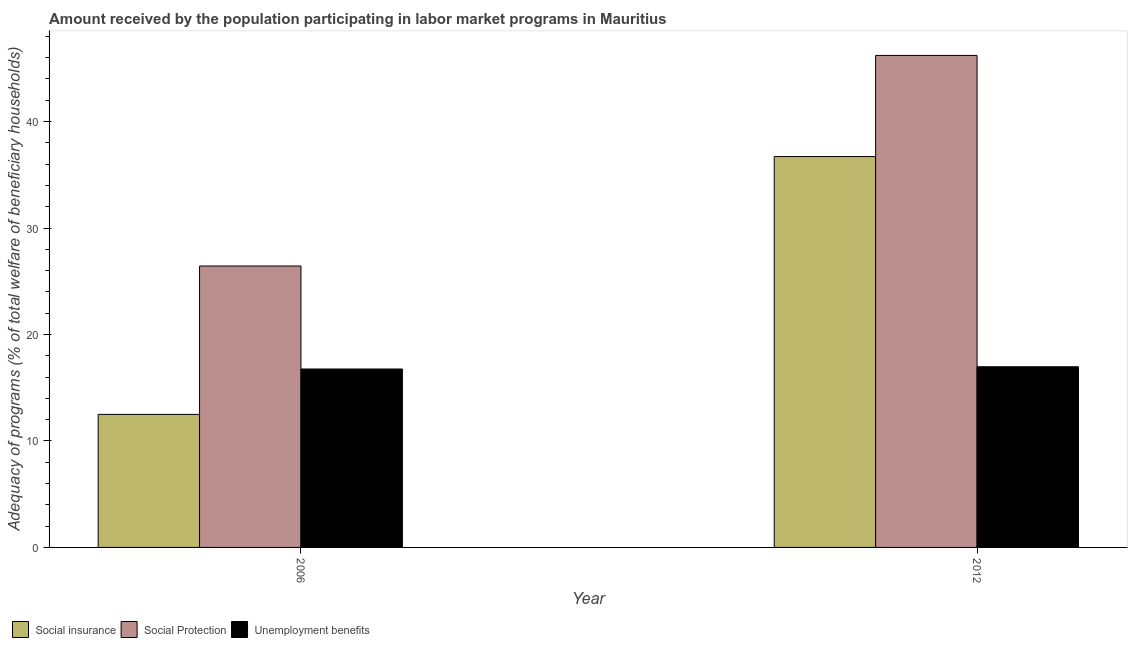How many bars are there on the 1st tick from the right?
Provide a short and direct response. 3. What is the label of the 2nd group of bars from the left?
Your response must be concise. 2012. What is the amount received by the population participating in social protection programs in 2006?
Offer a terse response. 26.43. Across all years, what is the maximum amount received by the population participating in social insurance programs?
Keep it short and to the point. 36.71. Across all years, what is the minimum amount received by the population participating in unemployment benefits programs?
Provide a succinct answer. 16.76. What is the total amount received by the population participating in social protection programs in the graph?
Your response must be concise. 72.64. What is the difference between the amount received by the population participating in unemployment benefits programs in 2006 and that in 2012?
Your response must be concise. -0.21. What is the difference between the amount received by the population participating in social protection programs in 2006 and the amount received by the population participating in unemployment benefits programs in 2012?
Offer a very short reply. -19.78. What is the average amount received by the population participating in unemployment benefits programs per year?
Offer a very short reply. 16.86. In the year 2012, what is the difference between the amount received by the population participating in social protection programs and amount received by the population participating in social insurance programs?
Provide a short and direct response. 0. What is the ratio of the amount received by the population participating in unemployment benefits programs in 2006 to that in 2012?
Make the answer very short. 0.99. Is the amount received by the population participating in unemployment benefits programs in 2006 less than that in 2012?
Your response must be concise. Yes. What does the 1st bar from the left in 2012 represents?
Make the answer very short. Social insurance. What does the 1st bar from the right in 2006 represents?
Your answer should be compact. Unemployment benefits. How many years are there in the graph?
Make the answer very short. 2. What is the difference between two consecutive major ticks on the Y-axis?
Provide a succinct answer. 10. Are the values on the major ticks of Y-axis written in scientific E-notation?
Offer a very short reply. No. Does the graph contain any zero values?
Make the answer very short. No. Does the graph contain grids?
Offer a very short reply. No. Where does the legend appear in the graph?
Ensure brevity in your answer.  Bottom left. What is the title of the graph?
Your answer should be very brief. Amount received by the population participating in labor market programs in Mauritius. Does "Negligence towards kids" appear as one of the legend labels in the graph?
Provide a short and direct response. No. What is the label or title of the Y-axis?
Provide a short and direct response. Adequacy of programs (% of total welfare of beneficiary households). What is the Adequacy of programs (% of total welfare of beneficiary households) of Social insurance in 2006?
Your answer should be very brief. 12.49. What is the Adequacy of programs (% of total welfare of beneficiary households) in Social Protection in 2006?
Make the answer very short. 26.43. What is the Adequacy of programs (% of total welfare of beneficiary households) of Unemployment benefits in 2006?
Ensure brevity in your answer.  16.76. What is the Adequacy of programs (% of total welfare of beneficiary households) of Social insurance in 2012?
Your answer should be compact. 36.71. What is the Adequacy of programs (% of total welfare of beneficiary households) in Social Protection in 2012?
Your answer should be very brief. 46.21. What is the Adequacy of programs (% of total welfare of beneficiary households) of Unemployment benefits in 2012?
Your answer should be very brief. 16.97. Across all years, what is the maximum Adequacy of programs (% of total welfare of beneficiary households) of Social insurance?
Make the answer very short. 36.71. Across all years, what is the maximum Adequacy of programs (% of total welfare of beneficiary households) of Social Protection?
Offer a very short reply. 46.21. Across all years, what is the maximum Adequacy of programs (% of total welfare of beneficiary households) of Unemployment benefits?
Provide a succinct answer. 16.97. Across all years, what is the minimum Adequacy of programs (% of total welfare of beneficiary households) of Social insurance?
Your answer should be compact. 12.49. Across all years, what is the minimum Adequacy of programs (% of total welfare of beneficiary households) of Social Protection?
Provide a succinct answer. 26.43. Across all years, what is the minimum Adequacy of programs (% of total welfare of beneficiary households) of Unemployment benefits?
Make the answer very short. 16.76. What is the total Adequacy of programs (% of total welfare of beneficiary households) of Social insurance in the graph?
Keep it short and to the point. 49.2. What is the total Adequacy of programs (% of total welfare of beneficiary households) of Social Protection in the graph?
Provide a short and direct response. 72.64. What is the total Adequacy of programs (% of total welfare of beneficiary households) in Unemployment benefits in the graph?
Your answer should be very brief. 33.73. What is the difference between the Adequacy of programs (% of total welfare of beneficiary households) in Social insurance in 2006 and that in 2012?
Provide a succinct answer. -24.22. What is the difference between the Adequacy of programs (% of total welfare of beneficiary households) in Social Protection in 2006 and that in 2012?
Offer a very short reply. -19.78. What is the difference between the Adequacy of programs (% of total welfare of beneficiary households) of Unemployment benefits in 2006 and that in 2012?
Give a very brief answer. -0.21. What is the difference between the Adequacy of programs (% of total welfare of beneficiary households) of Social insurance in 2006 and the Adequacy of programs (% of total welfare of beneficiary households) of Social Protection in 2012?
Offer a very short reply. -33.71. What is the difference between the Adequacy of programs (% of total welfare of beneficiary households) of Social insurance in 2006 and the Adequacy of programs (% of total welfare of beneficiary households) of Unemployment benefits in 2012?
Keep it short and to the point. -4.47. What is the difference between the Adequacy of programs (% of total welfare of beneficiary households) in Social Protection in 2006 and the Adequacy of programs (% of total welfare of beneficiary households) in Unemployment benefits in 2012?
Provide a short and direct response. 9.46. What is the average Adequacy of programs (% of total welfare of beneficiary households) in Social insurance per year?
Your answer should be compact. 24.6. What is the average Adequacy of programs (% of total welfare of beneficiary households) of Social Protection per year?
Provide a succinct answer. 36.32. What is the average Adequacy of programs (% of total welfare of beneficiary households) in Unemployment benefits per year?
Provide a succinct answer. 16.86. In the year 2006, what is the difference between the Adequacy of programs (% of total welfare of beneficiary households) in Social insurance and Adequacy of programs (% of total welfare of beneficiary households) in Social Protection?
Give a very brief answer. -13.94. In the year 2006, what is the difference between the Adequacy of programs (% of total welfare of beneficiary households) in Social insurance and Adequacy of programs (% of total welfare of beneficiary households) in Unemployment benefits?
Give a very brief answer. -4.26. In the year 2006, what is the difference between the Adequacy of programs (% of total welfare of beneficiary households) of Social Protection and Adequacy of programs (% of total welfare of beneficiary households) of Unemployment benefits?
Your answer should be compact. 9.67. In the year 2012, what is the difference between the Adequacy of programs (% of total welfare of beneficiary households) of Social insurance and Adequacy of programs (% of total welfare of beneficiary households) of Social Protection?
Your answer should be very brief. -9.5. In the year 2012, what is the difference between the Adequacy of programs (% of total welfare of beneficiary households) in Social insurance and Adequacy of programs (% of total welfare of beneficiary households) in Unemployment benefits?
Give a very brief answer. 19.74. In the year 2012, what is the difference between the Adequacy of programs (% of total welfare of beneficiary households) in Social Protection and Adequacy of programs (% of total welfare of beneficiary households) in Unemployment benefits?
Make the answer very short. 29.24. What is the ratio of the Adequacy of programs (% of total welfare of beneficiary households) in Social insurance in 2006 to that in 2012?
Offer a terse response. 0.34. What is the ratio of the Adequacy of programs (% of total welfare of beneficiary households) in Social Protection in 2006 to that in 2012?
Give a very brief answer. 0.57. What is the ratio of the Adequacy of programs (% of total welfare of beneficiary households) in Unemployment benefits in 2006 to that in 2012?
Give a very brief answer. 0.99. What is the difference between the highest and the second highest Adequacy of programs (% of total welfare of beneficiary households) of Social insurance?
Ensure brevity in your answer.  24.22. What is the difference between the highest and the second highest Adequacy of programs (% of total welfare of beneficiary households) of Social Protection?
Offer a very short reply. 19.78. What is the difference between the highest and the second highest Adequacy of programs (% of total welfare of beneficiary households) of Unemployment benefits?
Give a very brief answer. 0.21. What is the difference between the highest and the lowest Adequacy of programs (% of total welfare of beneficiary households) of Social insurance?
Keep it short and to the point. 24.22. What is the difference between the highest and the lowest Adequacy of programs (% of total welfare of beneficiary households) of Social Protection?
Offer a terse response. 19.78. What is the difference between the highest and the lowest Adequacy of programs (% of total welfare of beneficiary households) in Unemployment benefits?
Offer a terse response. 0.21. 